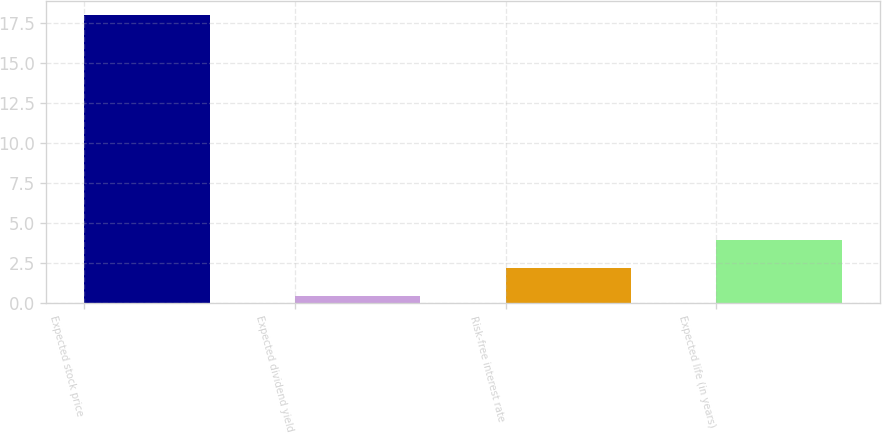<chart> <loc_0><loc_0><loc_500><loc_500><bar_chart><fcel>Expected stock price<fcel>Expected dividend yield<fcel>Risk-free interest rate<fcel>Expected life (in years)<nl><fcel>18<fcel>0.4<fcel>2.16<fcel>3.92<nl></chart> 